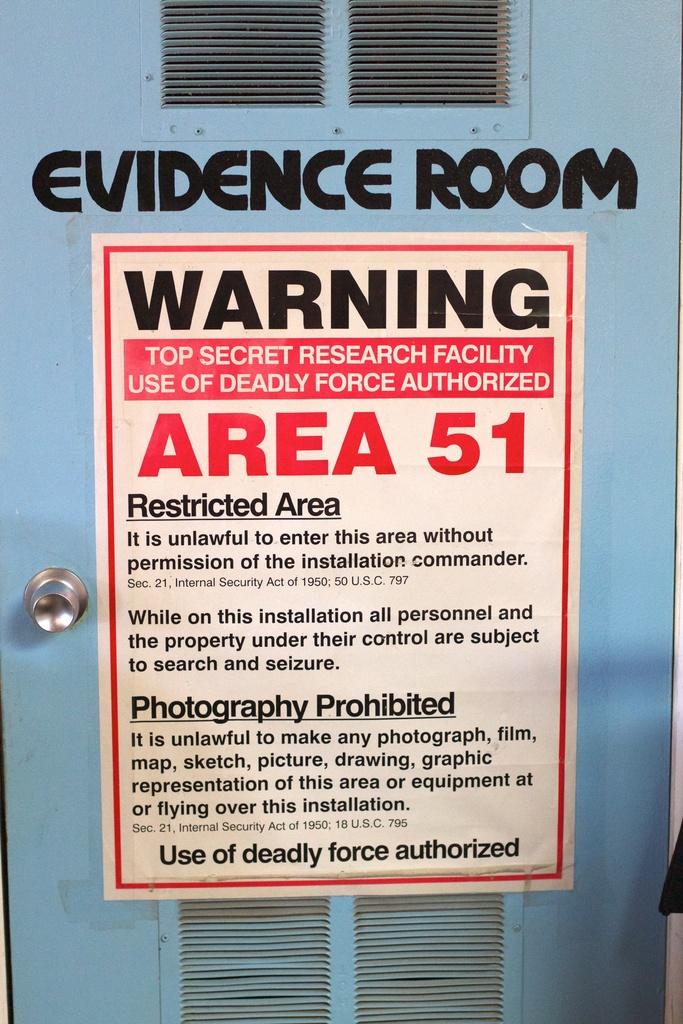What is prohibited in the room?
Offer a very short reply. Photography. What kind of room is this?
Your answer should be very brief. Evidence room. 